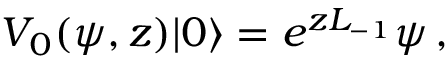<formula> <loc_0><loc_0><loc_500><loc_500>V _ { 0 } ( \psi , z ) | 0 \rangle = e ^ { z L _ { - 1 } } \psi \, ,</formula> 